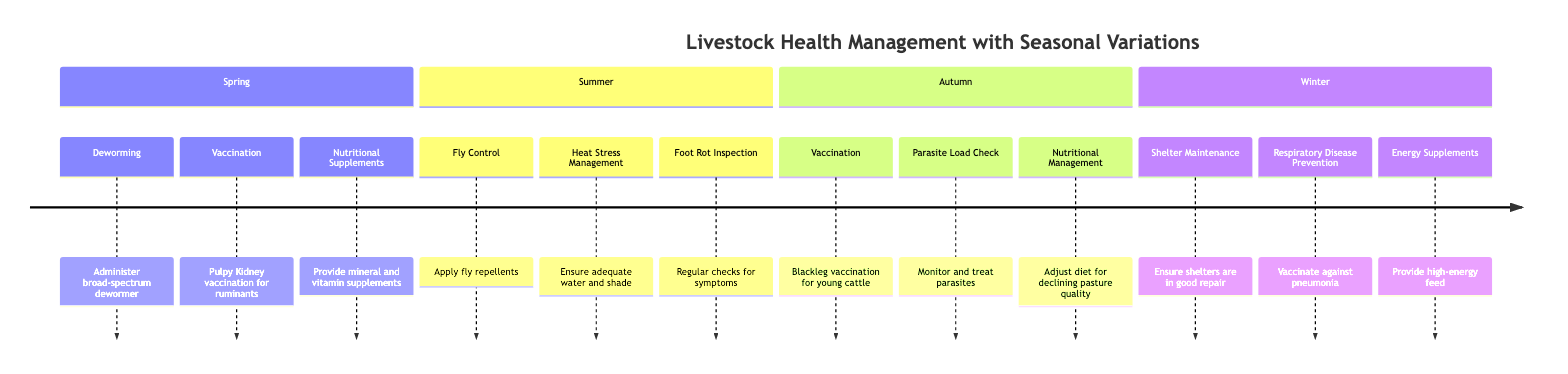What health management practice is recommended in Spring? According to the diagram, in the Spring season, the recommended health management practice is "Administer broad-spectrum dewormer." This is directly listed under the Spring section.
Answer: Administer broad-spectrum dewormer How many health management practices are listed for Autumn? Looking at the Autumn section of the diagram, there are three practices mentioned: "Blackleg vaccination for young cattle," "Monitor and treat parasites," and "Adjust diet for declining pasture quality." Therefore, there are a total of three practices.
Answer: 3 What specific vaccination is administered in Summer? The diagram does not mention any vaccinations for the Summer season. Therefore, there is no vaccination listed specifically for Summer.
Answer: None Which season emphasizes energy supplements? Referring to the Winter section of the diagram, energy supplements are specifically mentioned as "Provide high-energy feed." This clarifies that the emphasis on energy supplements occurs in Winter.
Answer: Winter What condition is checked for during the Summer? In the Summer season, the diagram indicates "Regular checks for symptoms" related to "Foot Rot Inspection." This means that this condition is monitored during the Summer.
Answer: Foot Rot Which vaccination is given to young cattle in Autumn? The Autumn section states the specific vaccination provided is "Blackleg vaccination for young cattle." This answers what vaccination is given to young cattle specifically in that season.
Answer: Blackleg vaccination for young cattle How does nutritional management change in Autumn? The Autumn section outlines that nutritional management involves "Adjust diet for declining pasture quality." This indicates a change in diet strategy to address the quality of pasture in that season.
Answer: Adjust diet for declining pasture quality What is a key component of respiratory disease prevention in Winter? The diagram specifies that in Winter, a key component of respiratory disease prevention is "Vaccinate against pneumonia." This action is clearly mentioned in the Winter section of the diagram.
Answer: Vaccinate against pneumonia 